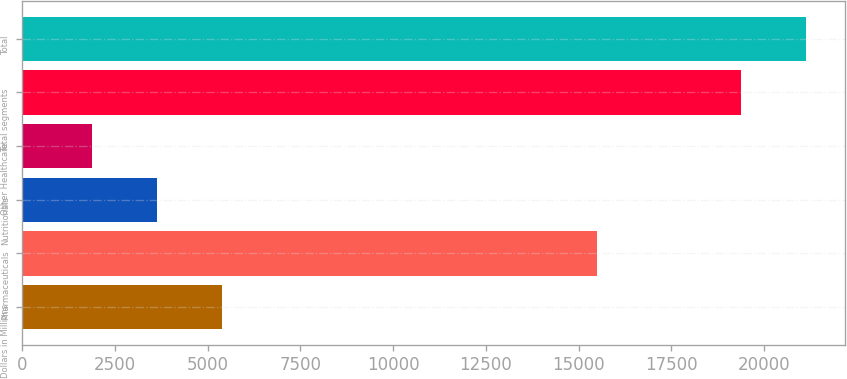<chart> <loc_0><loc_0><loc_500><loc_500><bar_chart><fcel>Dollars in Millions<fcel>Pharmaceuticals<fcel>Nutritionals<fcel>Other Healthcare<fcel>Total segments<fcel>Total<nl><fcel>5393.6<fcel>15482<fcel>3645.3<fcel>1897<fcel>19380<fcel>21128.3<nl></chart> 